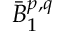<formula> <loc_0><loc_0><loc_500><loc_500>{ \bar { B } } _ { 1 } ^ { p , q }</formula> 